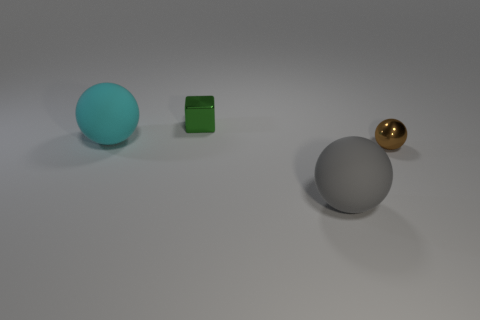What is the texture and color of the object furthest to the left? The object furthest to the left has a matte texture and is cyan in color. It appears to be a solid sphere with no visible patterns or additional colors. 